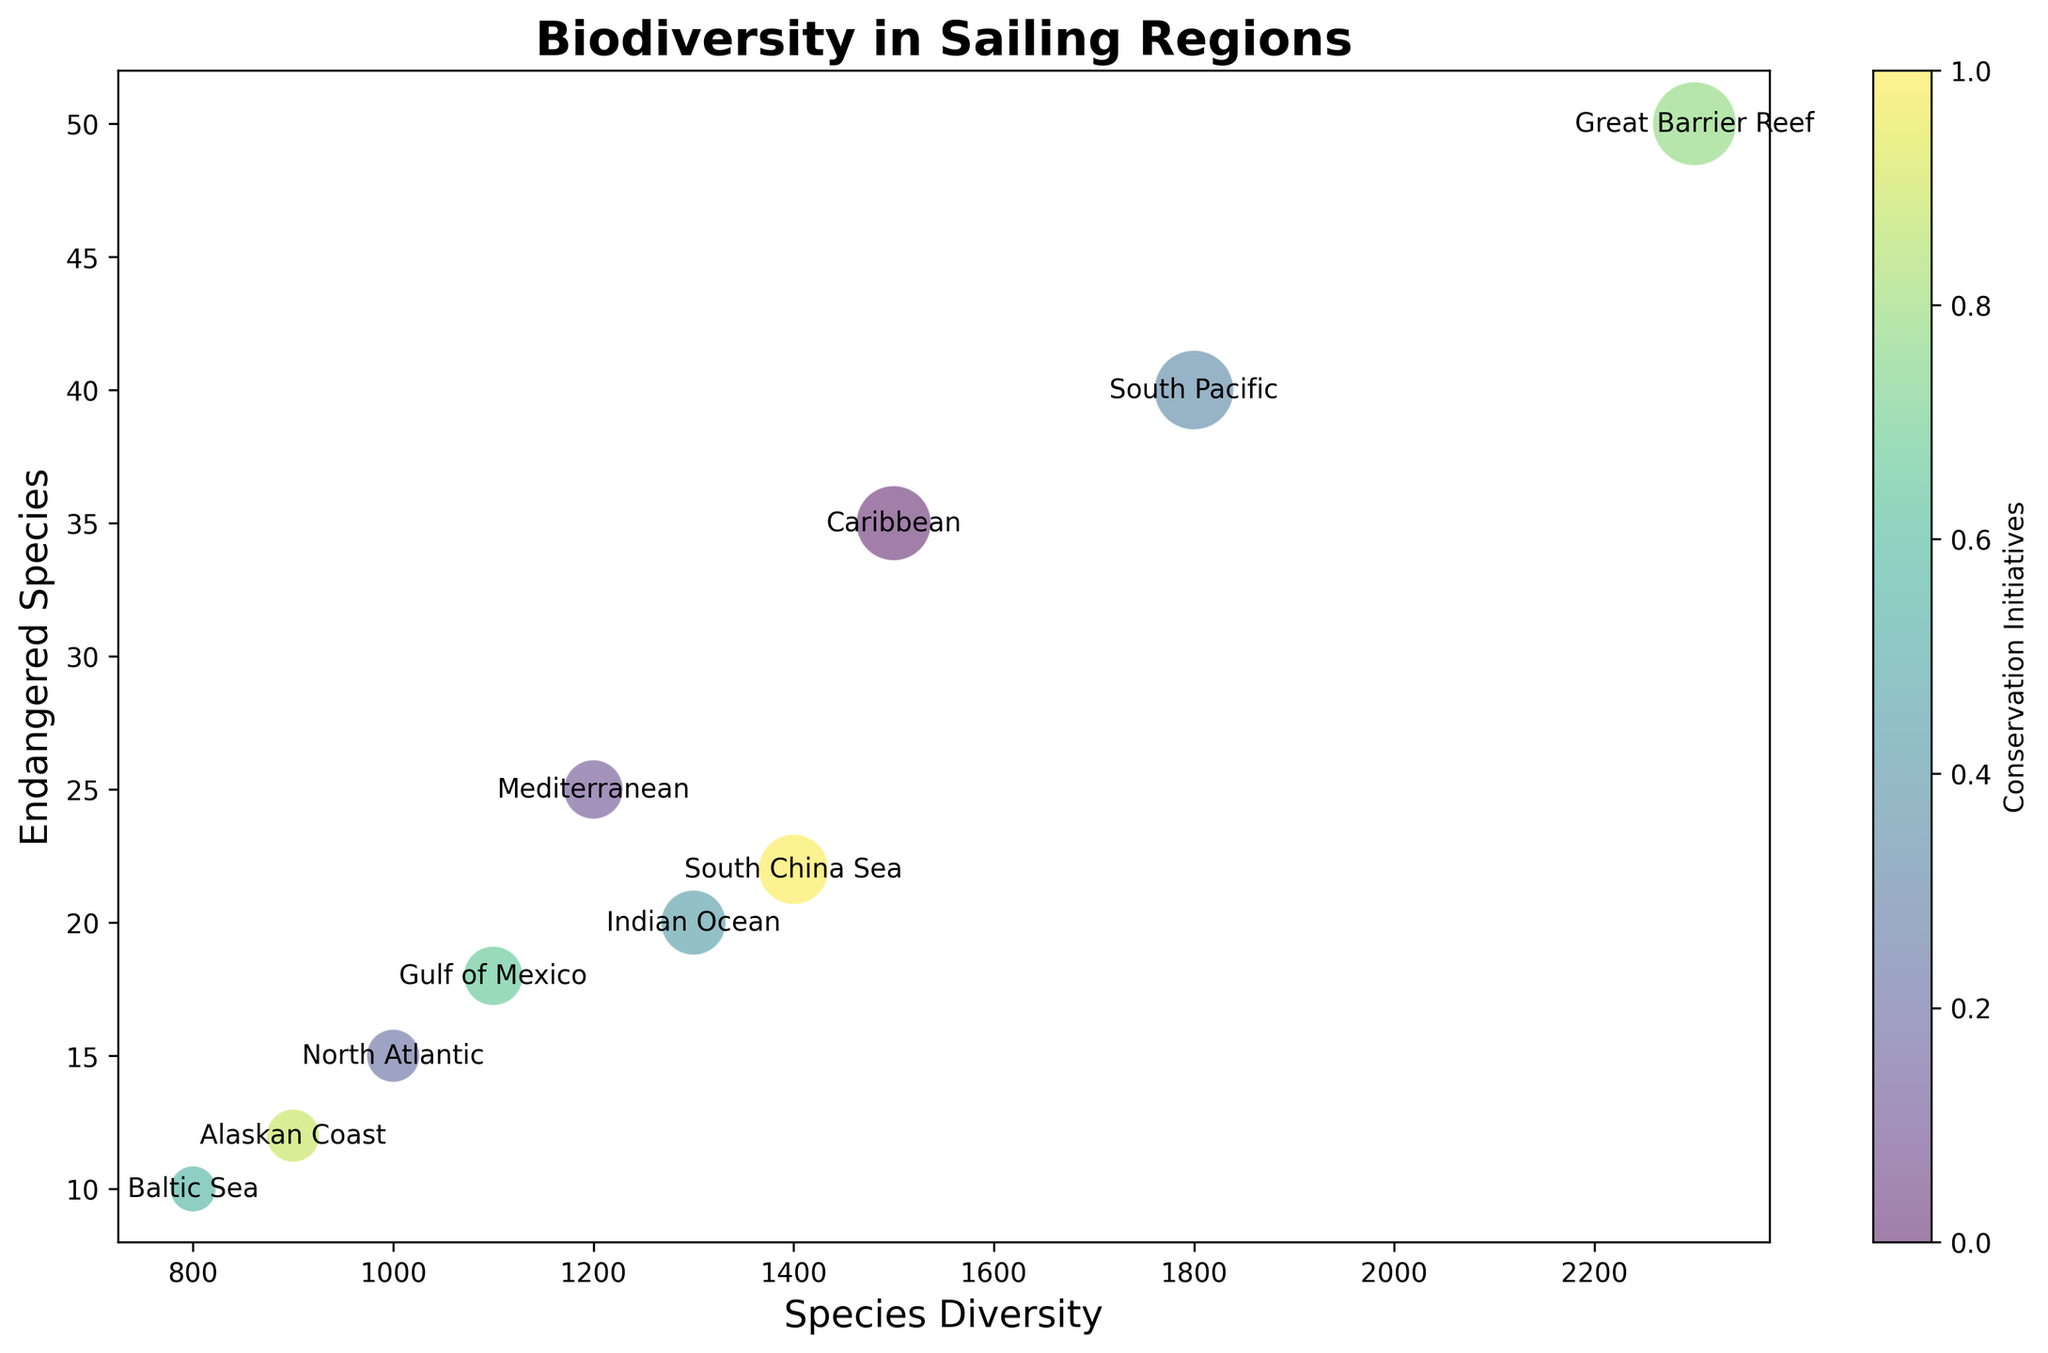What region has the highest species diversity? Look at the scatter plot and find the region that has the highest x-coordinate value, which represents species diversity. The region with the highest species diversity is "Great Barrier Reef" at 2300 species.
Answer: Great Barrier Reef Which region has the most significant number of endangered species? Find the bubble positioned highest on the y-axis (endangered species). This represents the region with the most endangered species. The region with the most endangered species is "Great Barrier Reef" at 50 species.
Answer: Great Barrier Reef What regions have more endangered species than the North Atlantic and more than three conservation initiatives? The North Atlantic has 15 endangered species and 4 conservation initiatives. Find all regions with more than 15 endangered species and more than 3 conservation initiatives: "Caribbean," "South Pacific," "Indian Ocean," "Gulf of Mexico," "Great Barrier Reef," and "South China Sea."
Answer: Caribbean, South Pacific, Indian Ocean, Gulf of Mexico, Great Barrier Reef, South China Sea How does species diversity correlate with the number of conservation initiatives? Observe the general trend in the scatter plot. Regions with higher species diversity tend to also have more conservation initiatives, as evident by the larger bubbles corresponding to higher species diversity values.
Answer: Positive correlation Compare the species diversity and endangered species between the Caribbean and Mediterranean regions. Check the coordinates of the bubbles for these regions. The Caribbean has 1500 species and 35 endangered species, while the Mediterranean has 1200 species and 25 endangered species. The Caribbean has higher species diversity and more endangered species than the Mediterranean.
Answer: Caribbean has higher What is the average species diversity of regions with 20 or more endangered species? Identify the regions with 20 or more endangered species (Caribbean, Mediterranean, South Pacific, Indian Ocean, Great Barrier Reef, South China Sea) and calculate their average species diversity: (1500 + 1200 + 1800 + 1300 + 2300 + 1400) / 6 = 9500 / 6 = 1583.33.
Answer: 1583.33 Which region with fewer than 10 conservation initiatives has the highest species diversity? Identify regions with fewer than 10 conservation initiatives and find the one with the highest species diversity: Caribbean (8 initiatives), Mediterranean (5), North Atlantic (4), Indian Ocean (6), Baltic Sea (3), Gulf of Mexico (5), Alaskan Coast (4), South China Sea (7). The region is "South Pacific" with 1800 species diversity and 9 initiatives.
Answer: South Pacific Is there any region with an equal number of endangered species and conservation initiatives? Check the y-coordinate (endangered species) and compare it with the bubble size indicator (conservation initiatives). No region has an equal number of endangered species and conservation initiatives.
Answer: No What is the total number of conservation initiatives across all regions? Add up the conservation initiatives from all regions: 8 + 5 + 4 + 9 + 6 + 3 + 5 + 10 + 4 + 7 = 61.
Answer: 61 How many regions have exactly four conservation initiatives? Look at the size of the bubbles indicating four conservation initiatives. The regions are "North Atlantic" and "Alaskan Coast." There are two such regions.
Answer: 2 